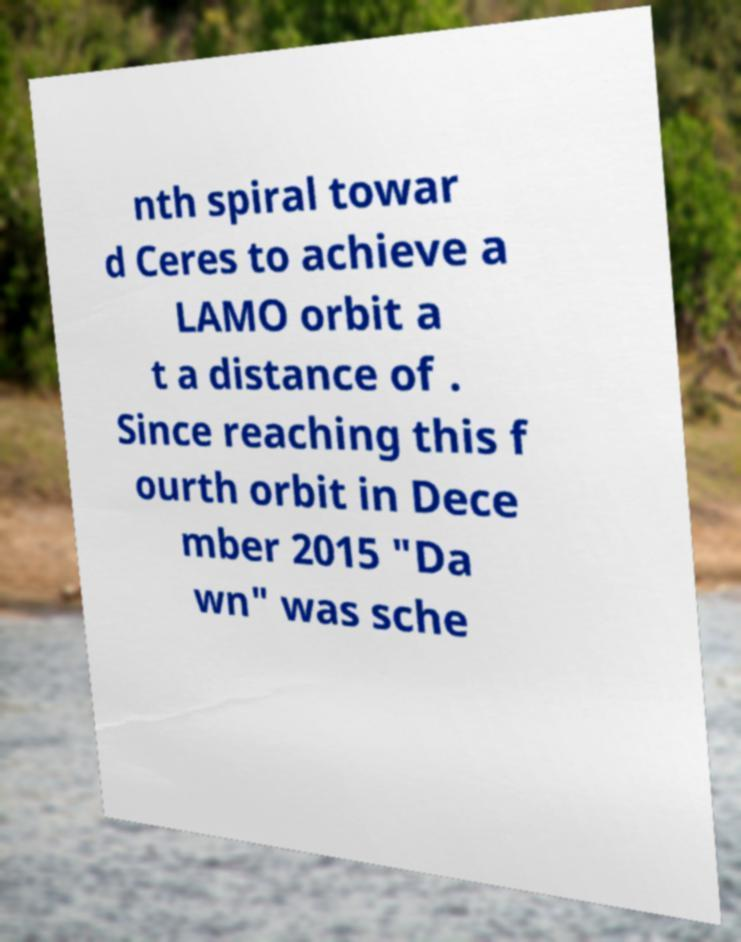For documentation purposes, I need the text within this image transcribed. Could you provide that? nth spiral towar d Ceres to achieve a LAMO orbit a t a distance of . Since reaching this f ourth orbit in Dece mber 2015 "Da wn" was sche 